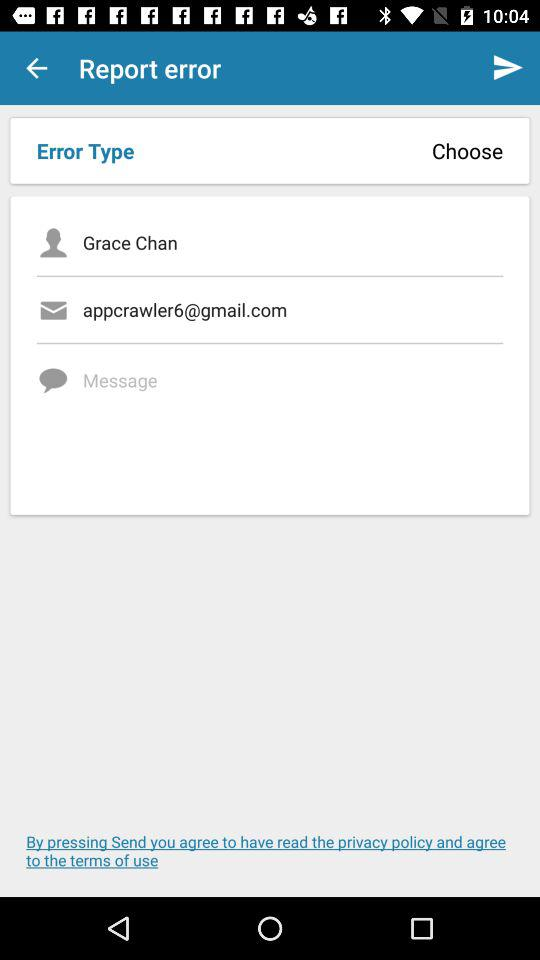What is the name? The name is Grace Chan. 